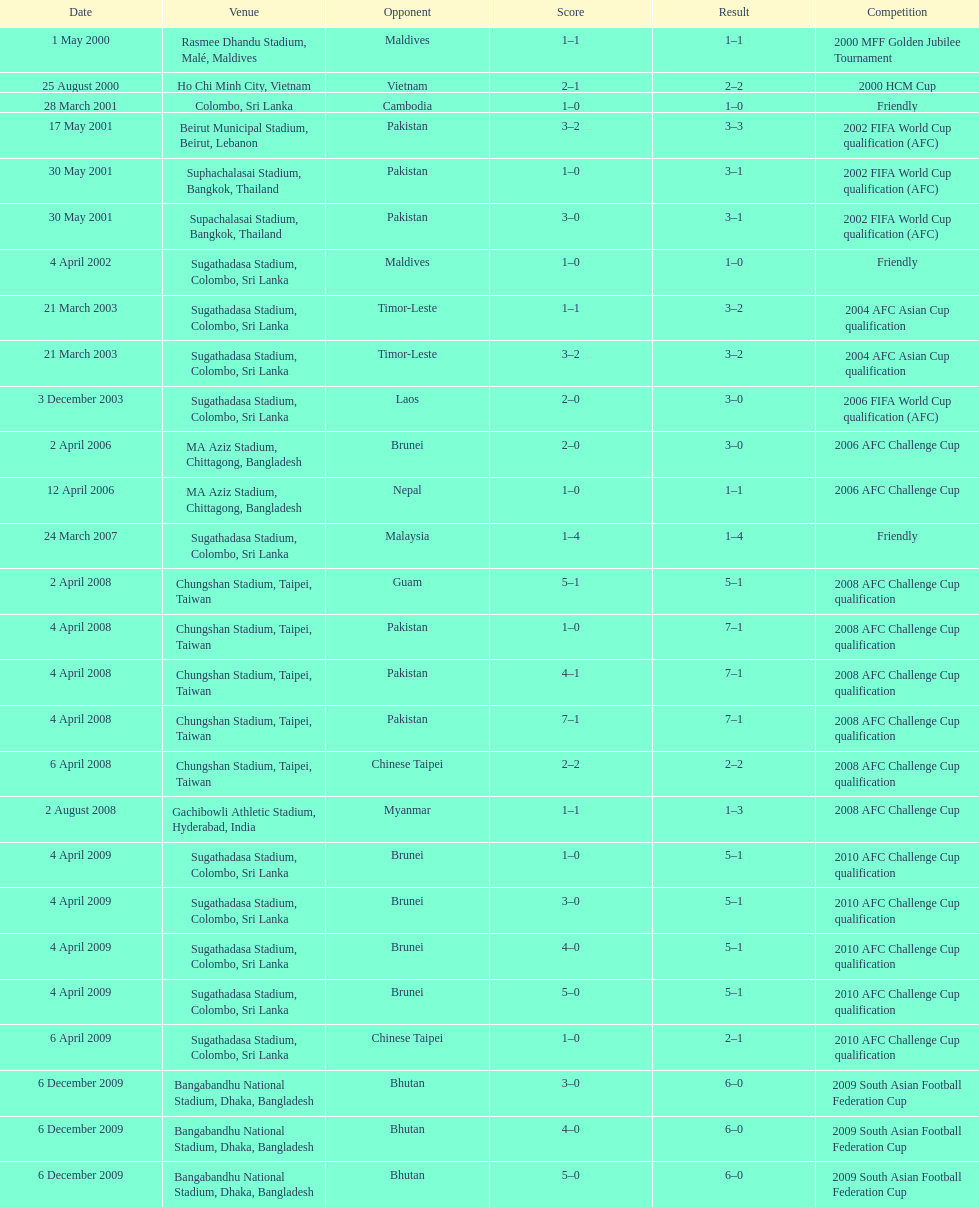Were more competitions played in april or december? April. 